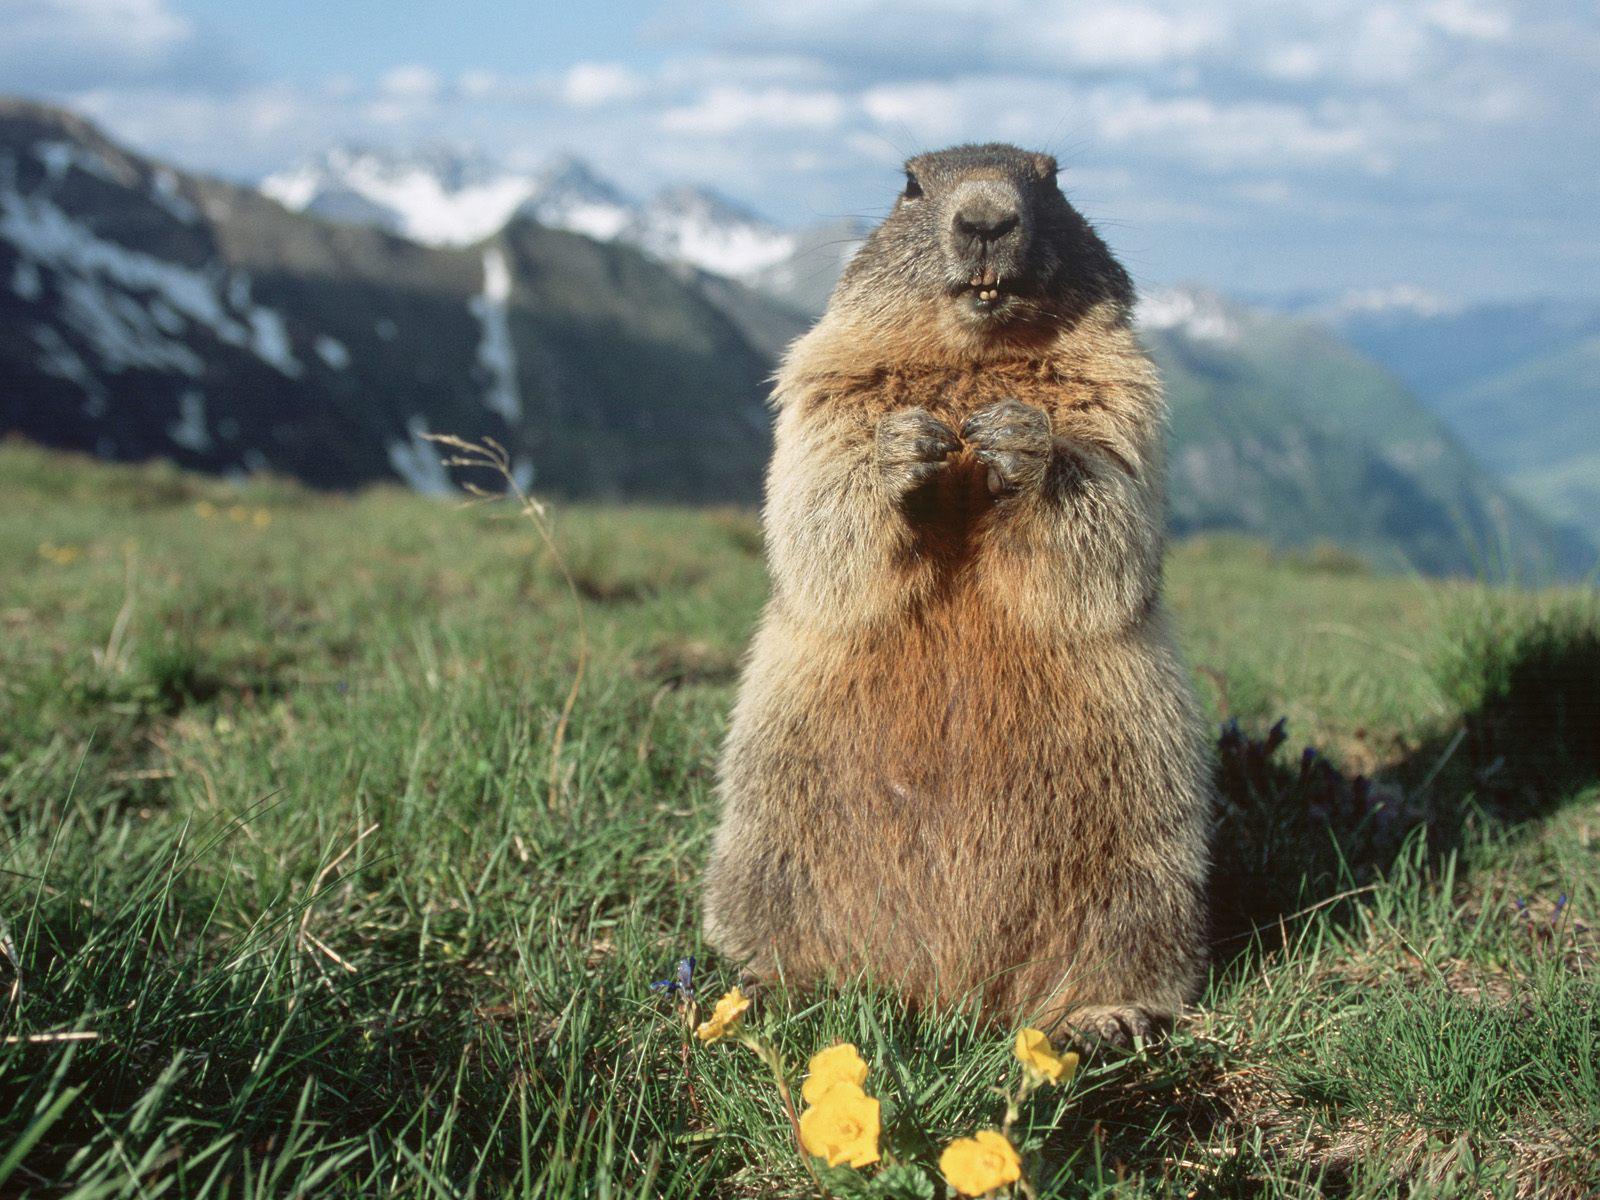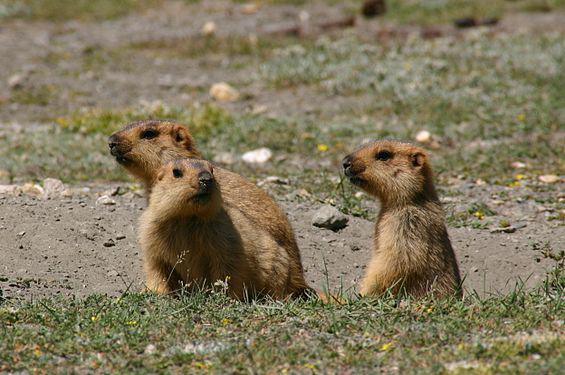The first image is the image on the left, the second image is the image on the right. Examine the images to the left and right. Is the description "Each image contains at least three marmots in a close grouping." accurate? Answer yes or no. No. 